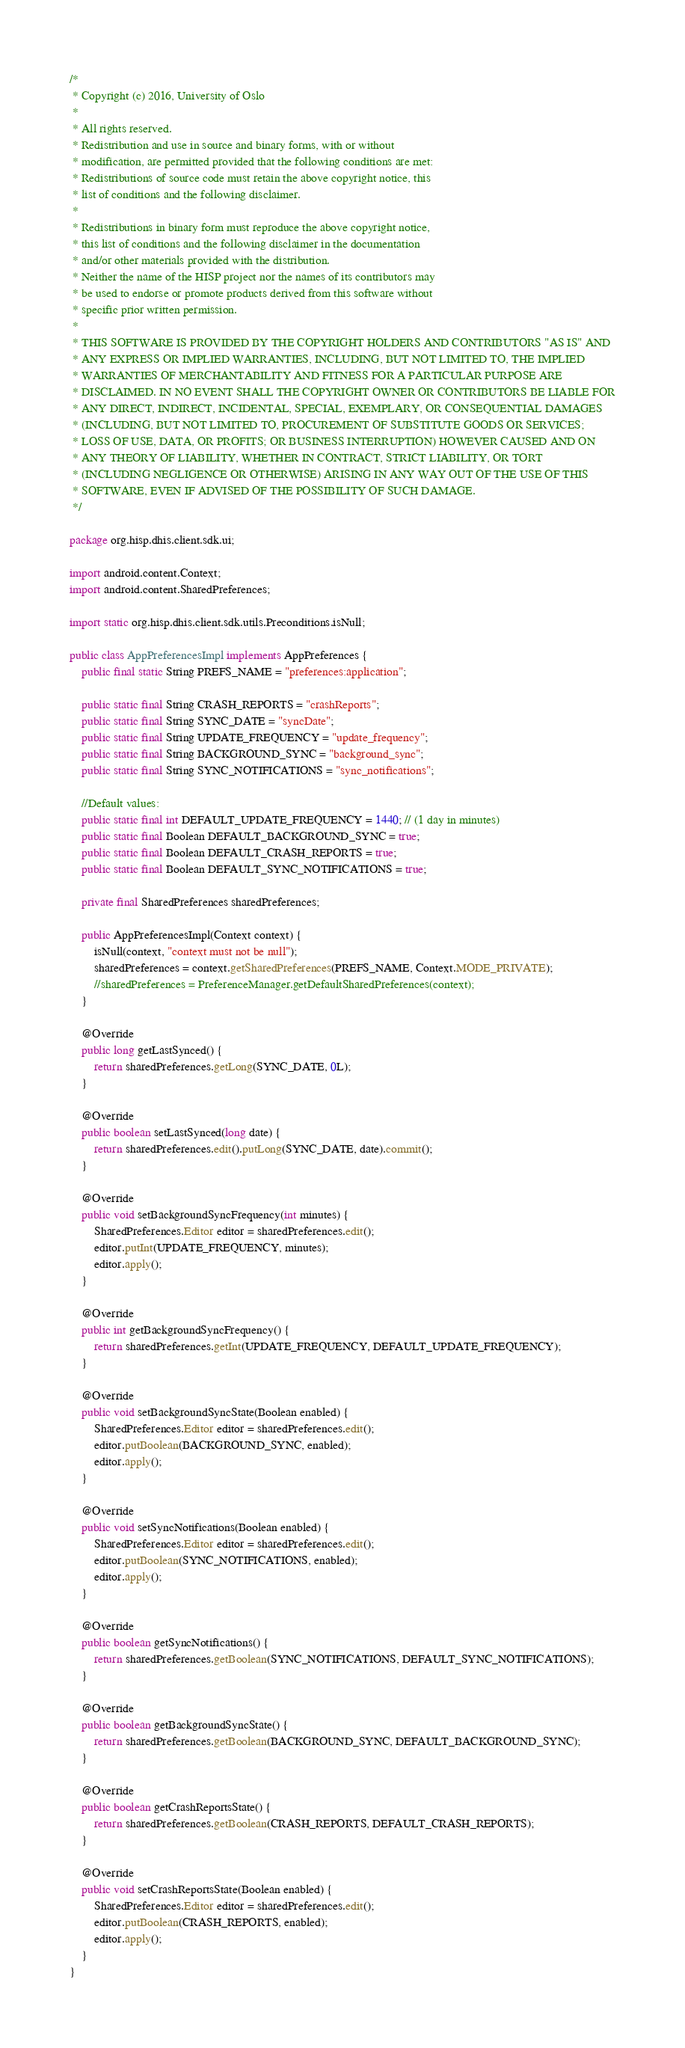Convert code to text. <code><loc_0><loc_0><loc_500><loc_500><_Java_>/*
 * Copyright (c) 2016, University of Oslo
 *
 * All rights reserved.
 * Redistribution and use in source and binary forms, with or without
 * modification, are permitted provided that the following conditions are met:
 * Redistributions of source code must retain the above copyright notice, this
 * list of conditions and the following disclaimer.
 *
 * Redistributions in binary form must reproduce the above copyright notice,
 * this list of conditions and the following disclaimer in the documentation
 * and/or other materials provided with the distribution.
 * Neither the name of the HISP project nor the names of its contributors may
 * be used to endorse or promote products derived from this software without
 * specific prior written permission.
 *
 * THIS SOFTWARE IS PROVIDED BY THE COPYRIGHT HOLDERS AND CONTRIBUTORS "AS IS" AND
 * ANY EXPRESS OR IMPLIED WARRANTIES, INCLUDING, BUT NOT LIMITED TO, THE IMPLIED
 * WARRANTIES OF MERCHANTABILITY AND FITNESS FOR A PARTICULAR PURPOSE ARE
 * DISCLAIMED. IN NO EVENT SHALL THE COPYRIGHT OWNER OR CONTRIBUTORS BE LIABLE FOR
 * ANY DIRECT, INDIRECT, INCIDENTAL, SPECIAL, EXEMPLARY, OR CONSEQUENTIAL DAMAGES
 * (INCLUDING, BUT NOT LIMITED TO, PROCUREMENT OF SUBSTITUTE GOODS OR SERVICES;
 * LOSS OF USE, DATA, OR PROFITS; OR BUSINESS INTERRUPTION) HOWEVER CAUSED AND ON
 * ANY THEORY OF LIABILITY, WHETHER IN CONTRACT, STRICT LIABILITY, OR TORT
 * (INCLUDING NEGLIGENCE OR OTHERWISE) ARISING IN ANY WAY OUT OF THE USE OF THIS
 * SOFTWARE, EVEN IF ADVISED OF THE POSSIBILITY OF SUCH DAMAGE.
 */

package org.hisp.dhis.client.sdk.ui;

import android.content.Context;
import android.content.SharedPreferences;

import static org.hisp.dhis.client.sdk.utils.Preconditions.isNull;

public class AppPreferencesImpl implements AppPreferences {
    public final static String PREFS_NAME = "preferences:application";

    public static final String CRASH_REPORTS = "crashReports";
    public static final String SYNC_DATE = "syncDate";
    public static final String UPDATE_FREQUENCY = "update_frequency";
    public static final String BACKGROUND_SYNC = "background_sync";
    public static final String SYNC_NOTIFICATIONS = "sync_notifications";

    //Default values:
    public static final int DEFAULT_UPDATE_FREQUENCY = 1440; // (1 day in minutes)
    public static final Boolean DEFAULT_BACKGROUND_SYNC = true;
    public static final Boolean DEFAULT_CRASH_REPORTS = true;
    public static final Boolean DEFAULT_SYNC_NOTIFICATIONS = true;

    private final SharedPreferences sharedPreferences;

    public AppPreferencesImpl(Context context) {
        isNull(context, "context must not be null");
        sharedPreferences = context.getSharedPreferences(PREFS_NAME, Context.MODE_PRIVATE);
        //sharedPreferences = PreferenceManager.getDefaultSharedPreferences(context);
    }

    @Override
    public long getLastSynced() {
        return sharedPreferences.getLong(SYNC_DATE, 0L);
    }

    @Override
    public boolean setLastSynced(long date) {
        return sharedPreferences.edit().putLong(SYNC_DATE, date).commit();
    }

    @Override
    public void setBackgroundSyncFrequency(int minutes) {
        SharedPreferences.Editor editor = sharedPreferences.edit();
        editor.putInt(UPDATE_FREQUENCY, minutes);
        editor.apply();
    }

    @Override
    public int getBackgroundSyncFrequency() {
        return sharedPreferences.getInt(UPDATE_FREQUENCY, DEFAULT_UPDATE_FREQUENCY);
    }

    @Override
    public void setBackgroundSyncState(Boolean enabled) {
        SharedPreferences.Editor editor = sharedPreferences.edit();
        editor.putBoolean(BACKGROUND_SYNC, enabled);
        editor.apply();
    }

    @Override
    public void setSyncNotifications(Boolean enabled) {
        SharedPreferences.Editor editor = sharedPreferences.edit();
        editor.putBoolean(SYNC_NOTIFICATIONS, enabled);
        editor.apply();
    }

    @Override
    public boolean getSyncNotifications() {
        return sharedPreferences.getBoolean(SYNC_NOTIFICATIONS, DEFAULT_SYNC_NOTIFICATIONS);
    }

    @Override
    public boolean getBackgroundSyncState() {
        return sharedPreferences.getBoolean(BACKGROUND_SYNC, DEFAULT_BACKGROUND_SYNC);
    }

    @Override
    public boolean getCrashReportsState() {
        return sharedPreferences.getBoolean(CRASH_REPORTS, DEFAULT_CRASH_REPORTS);
    }

    @Override
    public void setCrashReportsState(Boolean enabled) {
        SharedPreferences.Editor editor = sharedPreferences.edit();
        editor.putBoolean(CRASH_REPORTS, enabled);
        editor.apply();
    }
}</code> 